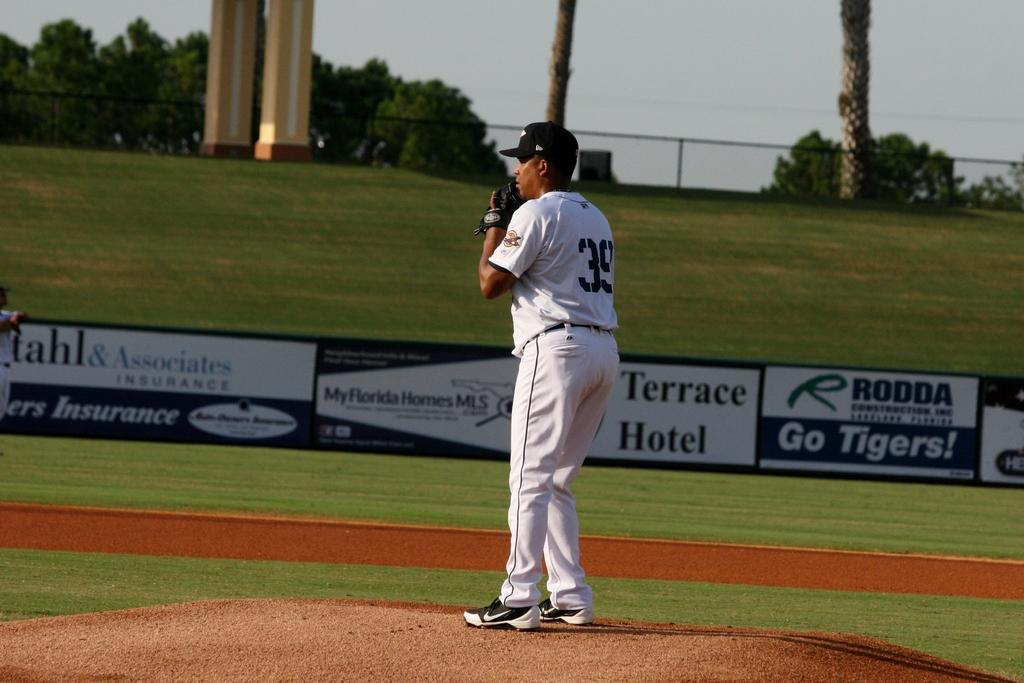<image>
Give a short and clear explanation of the subsequent image. Player number 39 on the mound prepares to face a batter. 